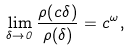<formula> <loc_0><loc_0><loc_500><loc_500>\lim _ { \delta \rightarrow 0 } \frac { \rho ( c \delta ) } { \rho ( \delta ) } = c ^ { \omega } ,</formula> 